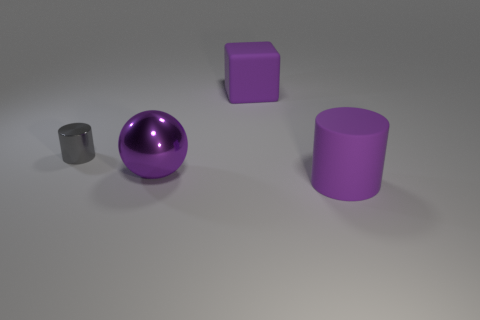Are there any cyan shiny blocks that have the same size as the matte cylinder? No, there are no cyan blocks present. All objects in the image appear to be shades of purple and grey, with a shiny purple sphere and a matte grey cylinder included. 